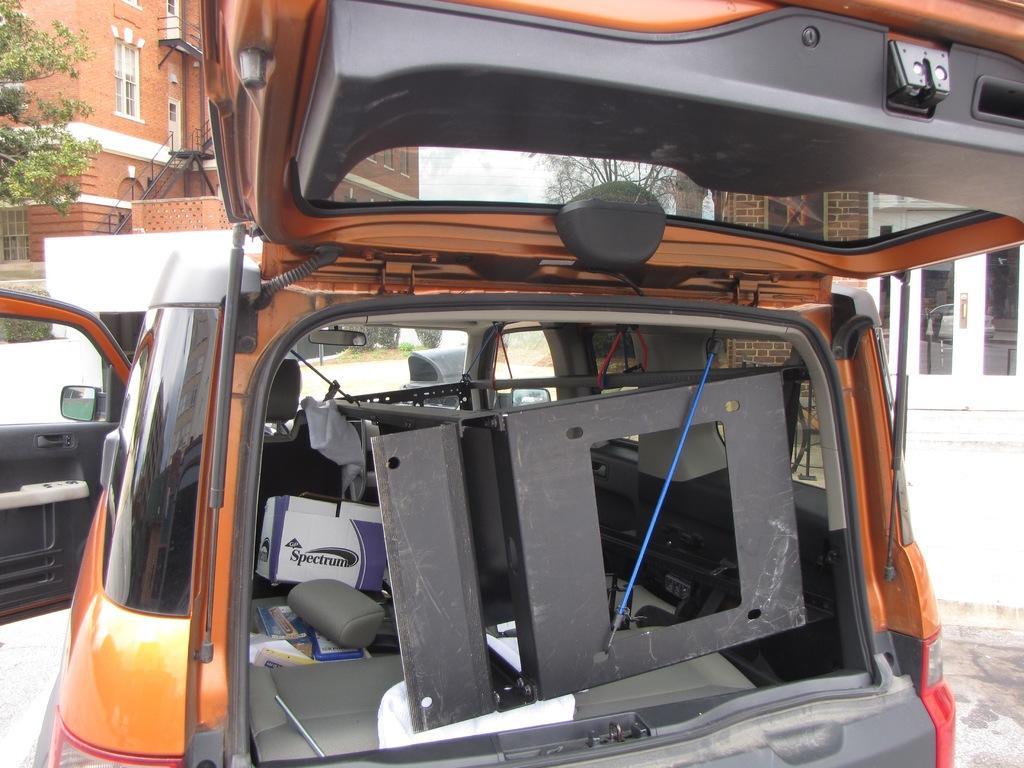In one or two sentences, can you explain what this image depicts? In this picture we can see a vehicle on the road with some objects in it and in the background we can see buildings with windows, doors and trees. 